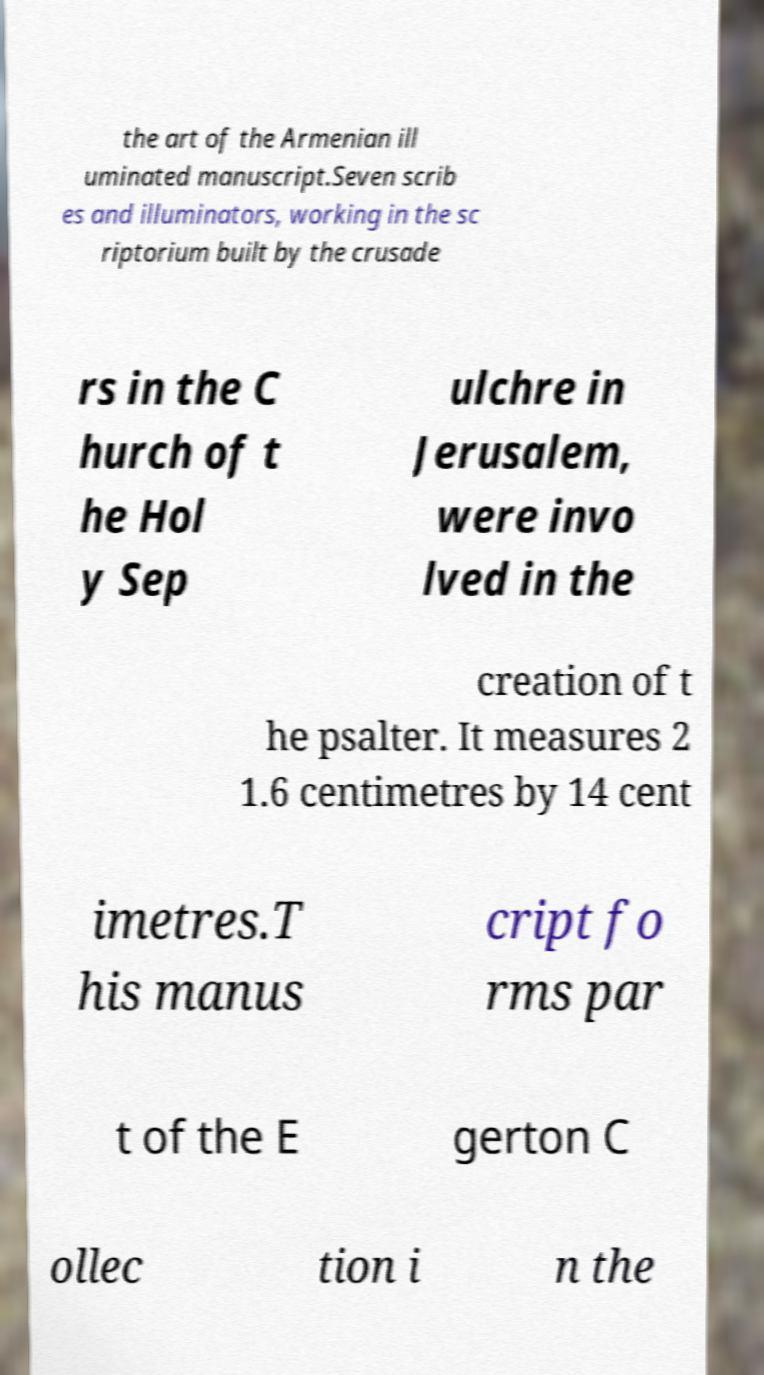Please read and relay the text visible in this image. What does it say? the art of the Armenian ill uminated manuscript.Seven scrib es and illuminators, working in the sc riptorium built by the crusade rs in the C hurch of t he Hol y Sep ulchre in Jerusalem, were invo lved in the creation of t he psalter. It measures 2 1.6 centimetres by 14 cent imetres.T his manus cript fo rms par t of the E gerton C ollec tion i n the 